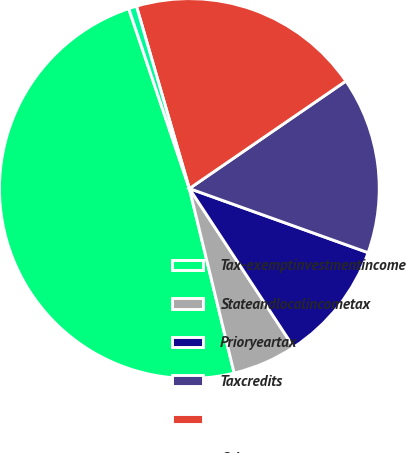Convert chart to OTSL. <chart><loc_0><loc_0><loc_500><loc_500><pie_chart><fcel>Tax-exemptinvestmentincome<fcel>Stateandlocalincometax<fcel>Prioryeartax<fcel>Taxcredits<fcel>Unnamed: 4<fcel>Othernet<nl><fcel>48.62%<fcel>5.47%<fcel>10.26%<fcel>15.06%<fcel>19.92%<fcel>0.68%<nl></chart> 